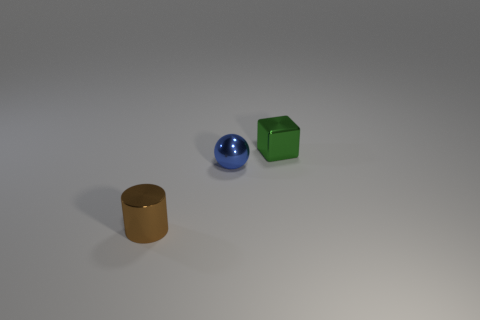Is there anything else that has the same shape as the tiny green thing?
Offer a terse response. No. What number of things are objects to the right of the tiny blue sphere or objects that are on the left side of the tiny blue shiny ball?
Make the answer very short. 2. There is a blue thing; is its shape the same as the metal thing behind the tiny blue sphere?
Offer a very short reply. No. How many other things are made of the same material as the tiny ball?
Your answer should be compact. 2. How many things are tiny metal objects behind the tiny sphere or small purple metallic objects?
Provide a succinct answer. 1. There is a shiny thing behind the blue thing; does it have the same shape as the brown object?
Ensure brevity in your answer.  No. What color is the small object left of the small blue shiny object?
Provide a short and direct response. Brown. What number of blocks are either green metal things or small objects?
Provide a short and direct response. 1. There is a metal cylinder; is its color the same as the metallic thing on the right side of the blue sphere?
Keep it short and to the point. No. There is a small blue ball; what number of small brown cylinders are in front of it?
Your answer should be compact. 1. 